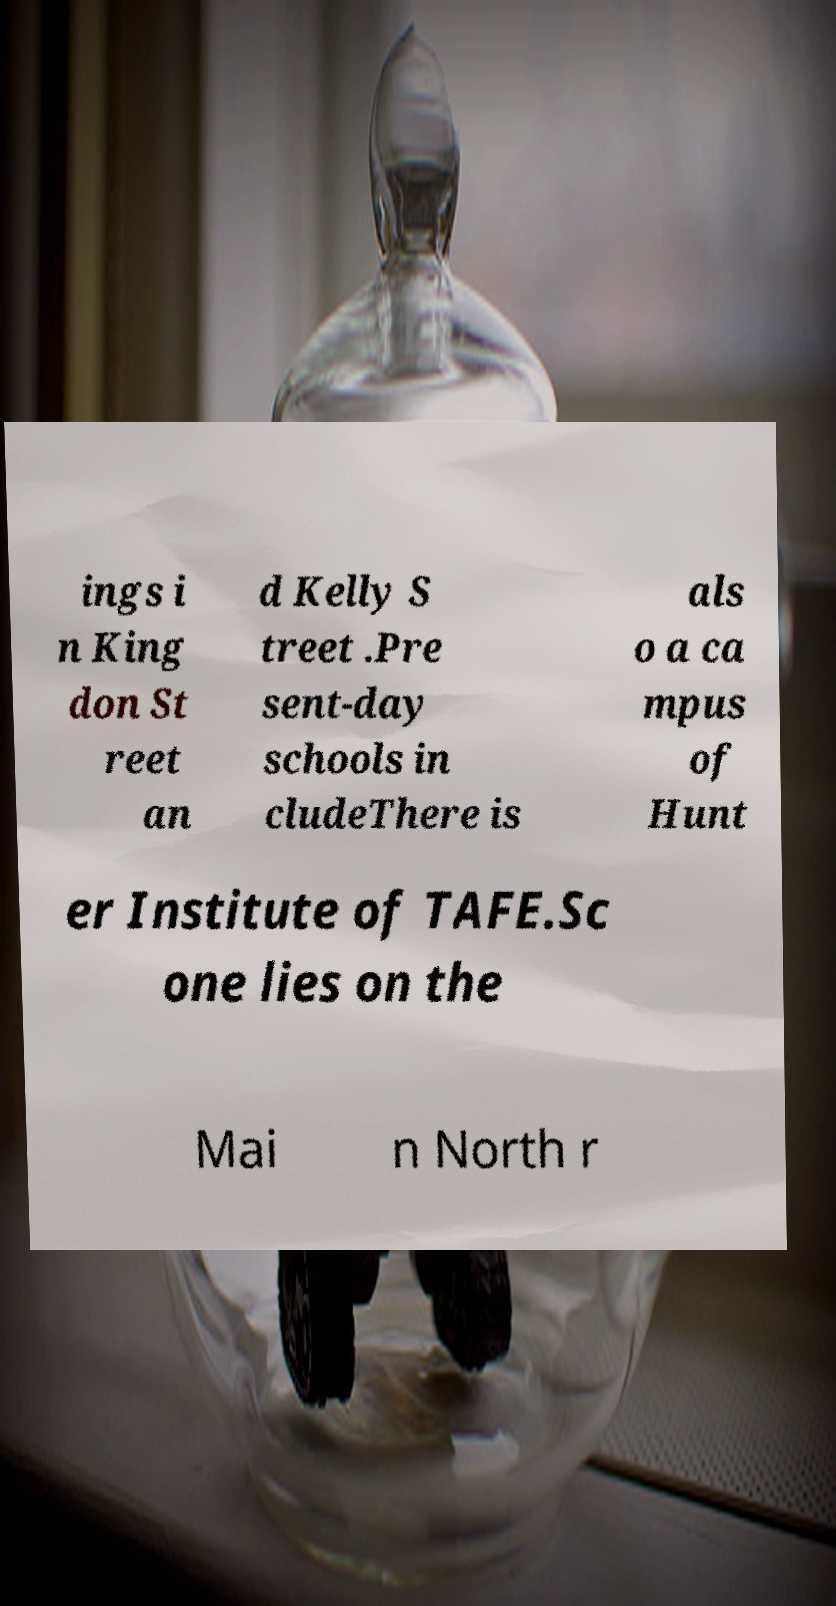I need the written content from this picture converted into text. Can you do that? ings i n King don St reet an d Kelly S treet .Pre sent-day schools in cludeThere is als o a ca mpus of Hunt er Institute of TAFE.Sc one lies on the Mai n North r 